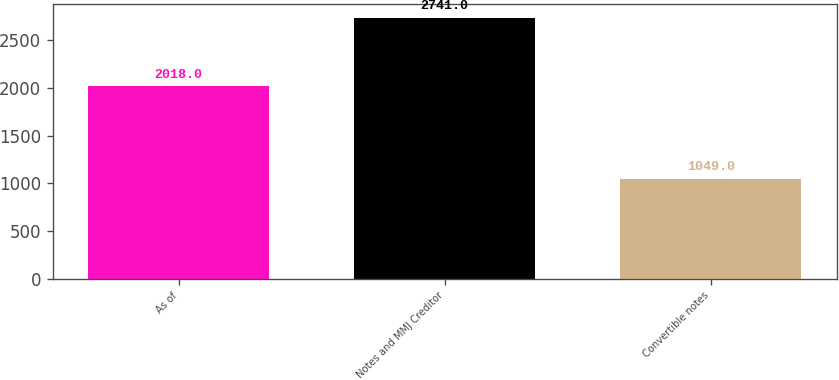Convert chart to OTSL. <chart><loc_0><loc_0><loc_500><loc_500><bar_chart><fcel>As of<fcel>Notes and MMJ Creditor<fcel>Convertible notes<nl><fcel>2018<fcel>2741<fcel>1049<nl></chart> 